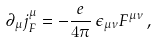Convert formula to latex. <formula><loc_0><loc_0><loc_500><loc_500>\partial _ { \mu } j _ { F } ^ { \mu } = - { \frac { e } { 4 \pi } } \, \epsilon _ { \mu \nu } F ^ { \mu \nu } \, ,</formula> 